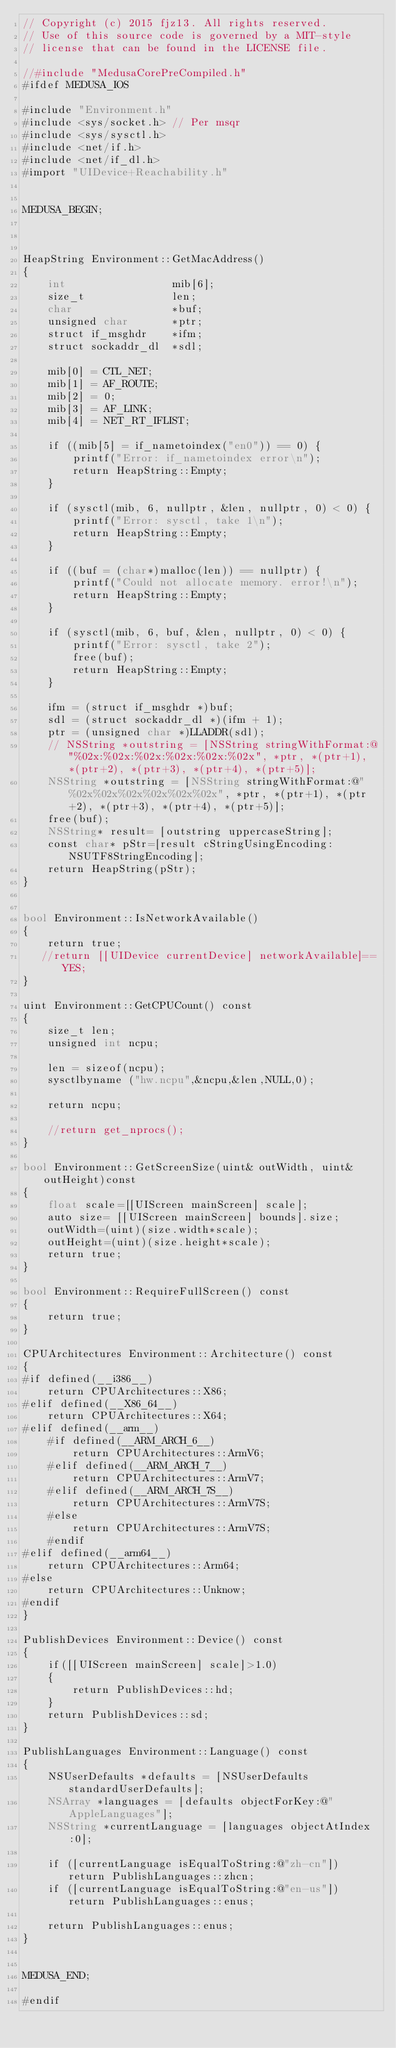Convert code to text. <code><loc_0><loc_0><loc_500><loc_500><_ObjectiveC_>// Copyright (c) 2015 fjz13. All rights reserved.
// Use of this source code is governed by a MIT-style
// license that can be found in the LICENSE file.

//#include "MedusaCorePreCompiled.h"
#ifdef MEDUSA_IOS

#include "Environment.h"
#include <sys/socket.h> // Per msqr
#include <sys/sysctl.h>
#include <net/if.h>
#include <net/if_dl.h>
#import "UIDevice+Reachability.h"


MEDUSA_BEGIN;



HeapString Environment::GetMacAddress()
{
	int					mib[6];
	size_t				len;
	char				*buf;
	unsigned char		*ptr;
	struct if_msghdr	*ifm;
	struct sockaddr_dl	*sdl;
	
	mib[0] = CTL_NET;
	mib[1] = AF_ROUTE;
	mib[2] = 0;
	mib[3] = AF_LINK;
	mib[4] = NET_RT_IFLIST;
	
	if ((mib[5] = if_nametoindex("en0")) == 0) {
		printf("Error: if_nametoindex error\n");
		return HeapString::Empty;
	}
	
	if (sysctl(mib, 6, nullptr, &len, nullptr, 0) < 0) {
		printf("Error: sysctl, take 1\n");
		return HeapString::Empty;
	}
	
	if ((buf = (char*)malloc(len)) == nullptr) {
		printf("Could not allocate memory. error!\n");
		return HeapString::Empty;
	}
	
	if (sysctl(mib, 6, buf, &len, nullptr, 0) < 0) {
		printf("Error: sysctl, take 2");
        free(buf);
		return HeapString::Empty;
	}
	
	ifm = (struct if_msghdr *)buf;
	sdl = (struct sockaddr_dl *)(ifm + 1);
	ptr = (unsigned char *)LLADDR(sdl);
	// NSString *outstring = [NSString stringWithFormat:@"%02x:%02x:%02x:%02x:%02x:%02x", *ptr, *(ptr+1), *(ptr+2), *(ptr+3), *(ptr+4), *(ptr+5)];
	NSString *outstring = [NSString stringWithFormat:@"%02x%02x%02x%02x%02x%02x", *ptr, *(ptr+1), *(ptr+2), *(ptr+3), *(ptr+4), *(ptr+5)];
	free(buf);
	NSString* result= [outstring uppercaseString];
	const char* pStr=[result cStringUsingEncoding:NSUTF8StringEncoding];
	return HeapString(pStr);
}


bool Environment::IsNetworkAvailable()
{
    return true;
   //return [[UIDevice currentDevice] networkAvailable]==YES;
}

uint Environment::GetCPUCount() const
{
    size_t len;
    unsigned int ncpu;
    
    len = sizeof(ncpu);
    sysctlbyname ("hw.ncpu",&ncpu,&len,NULL,0);
    
    return ncpu;

	//return get_nprocs();
}

bool Environment::GetScreenSize(uint& outWidth, uint& outHeight)const
{
    float scale=[[UIScreen mainScreen] scale];
	auto size= [[UIScreen mainScreen] bounds].size;
	outWidth=(uint)(size.width*scale);
	outHeight=(uint)(size.height*scale);
	return true;
}

bool Environment::RequireFullScreen() const
{
	return true;
}

CPUArchitectures Environment::Architecture() const
{
#if defined(__i386__)
	return CPUArchitectures::X86;
#elif defined(__X86_64__)
	return CPUArchitectures::X64;
#elif defined(__arm__)
	#if defined(__ARM_ARCH_6__)
		return CPUArchitectures::ArmV6;
	#elif defined(__ARM_ARCH_7__)
		return CPUArchitectures::ArmV7;
	#elif defined(__ARM_ARCH_7S__)
		return CPUArchitectures::ArmV7S;
	#else
		return CPUArchitectures::ArmV7S;
	#endif
#elif defined(__arm64__)
	return CPUArchitectures::Arm64;
#else
	return CPUArchitectures::Unknow;
#endif
}

PublishDevices Environment::Device() const
{
	if([[UIScreen mainScreen] scale]>1.0)
	{
		return PublishDevices::hd;
	}
	return PublishDevices::sd;
}

PublishLanguages Environment::Language() const
{
	NSUserDefaults *defaults = [NSUserDefaults standardUserDefaults];
    NSArray *languages = [defaults objectForKey:@"AppleLanguages"];
    NSString *currentLanguage = [languages objectAtIndex:0];

	if ([currentLanguage isEqualToString:@"zh-cn"]) return PublishLanguages::zhcn;
	if ([currentLanguage isEqualToString:@"en-us"]) return PublishLanguages::enus;

	return PublishLanguages::enus;
}


MEDUSA_END;

#endif</code> 